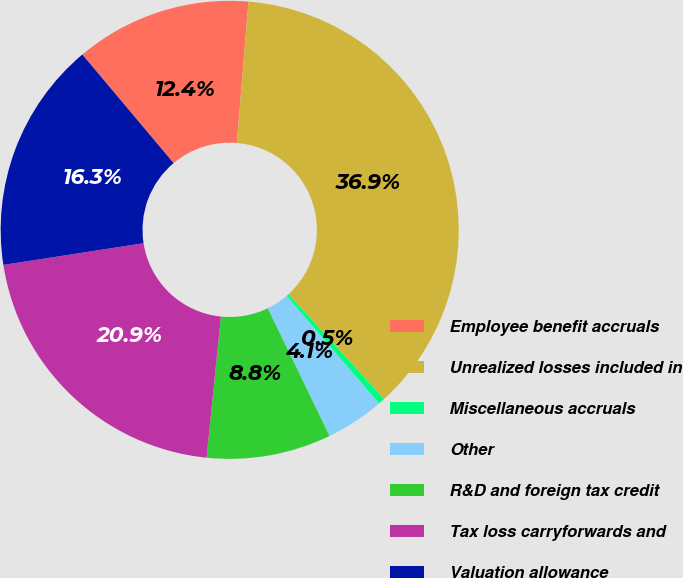<chart> <loc_0><loc_0><loc_500><loc_500><pie_chart><fcel>Employee benefit accruals<fcel>Unrealized losses included in<fcel>Miscellaneous accruals<fcel>Other<fcel>R&D and foreign tax credit<fcel>Tax loss carryforwards and<fcel>Valuation allowance<nl><fcel>12.43%<fcel>36.91%<fcel>0.48%<fcel>4.12%<fcel>8.79%<fcel>20.94%<fcel>16.32%<nl></chart> 